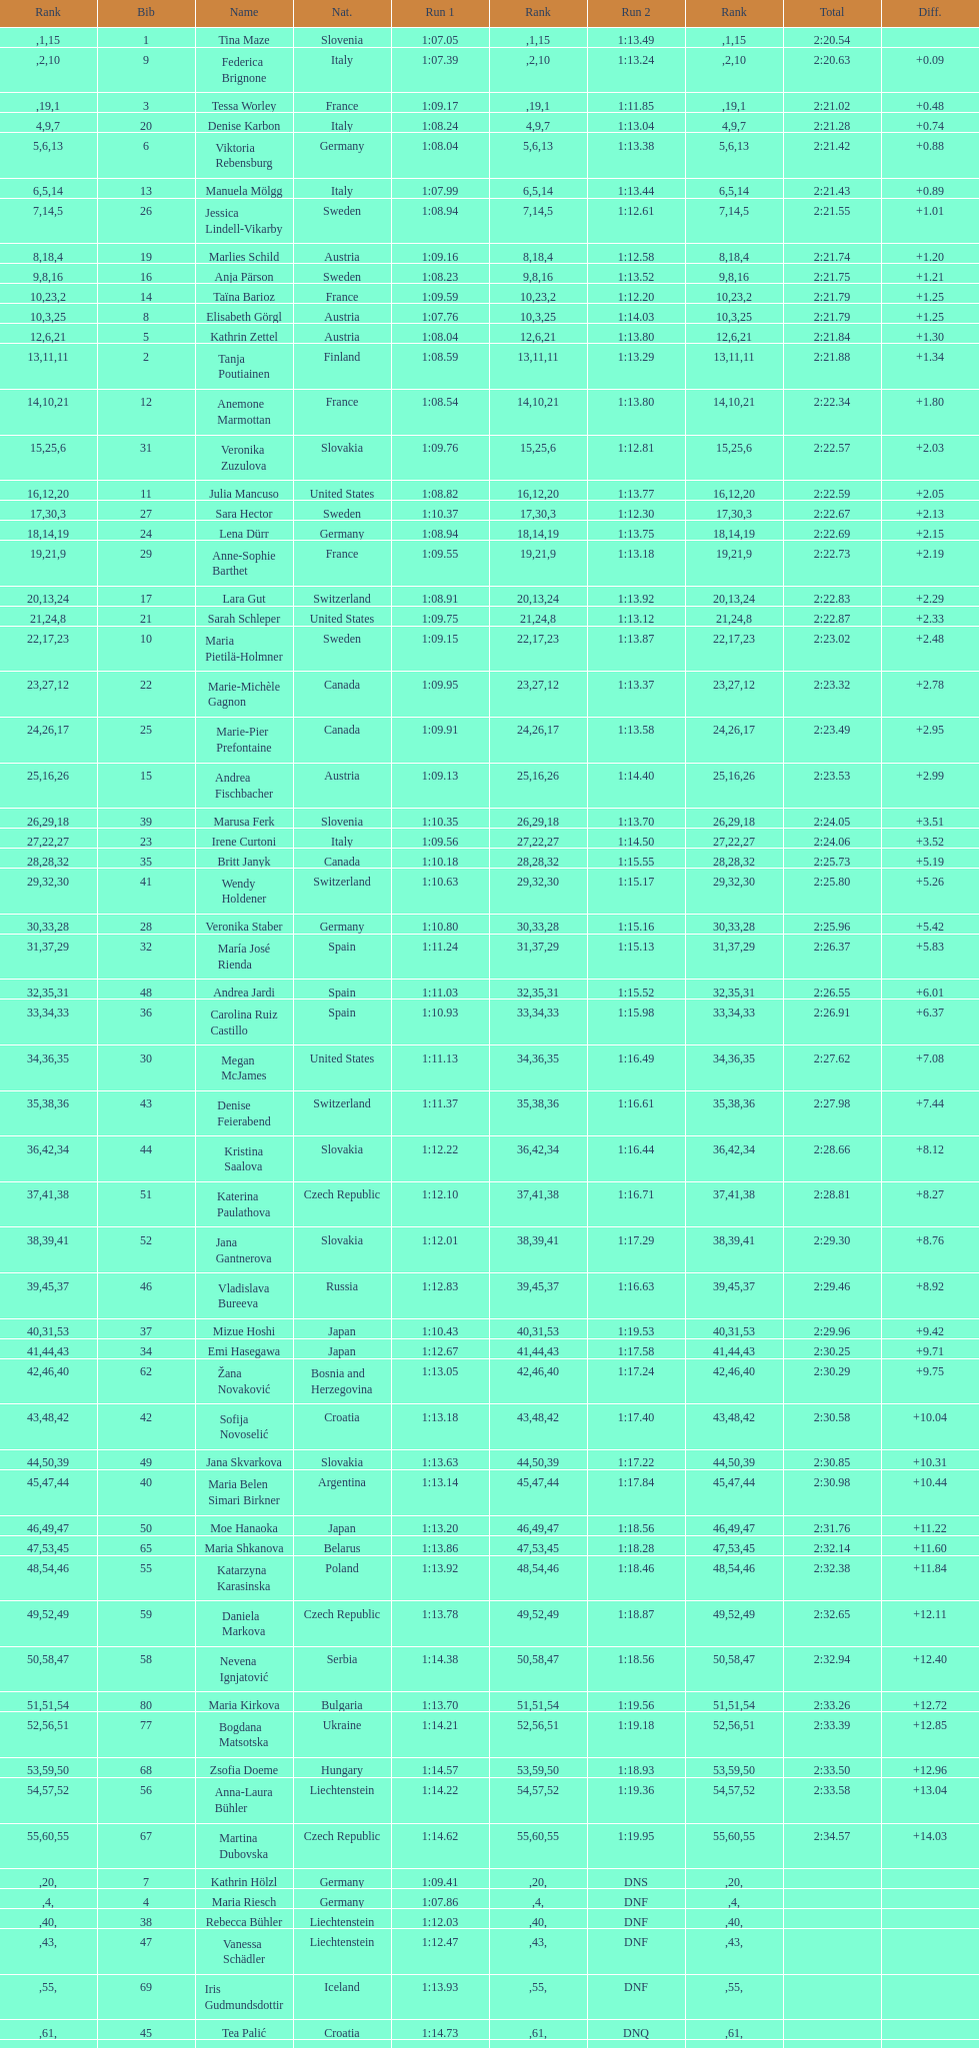How many athletes had the same rank for both run 1 and run 2? 1. 